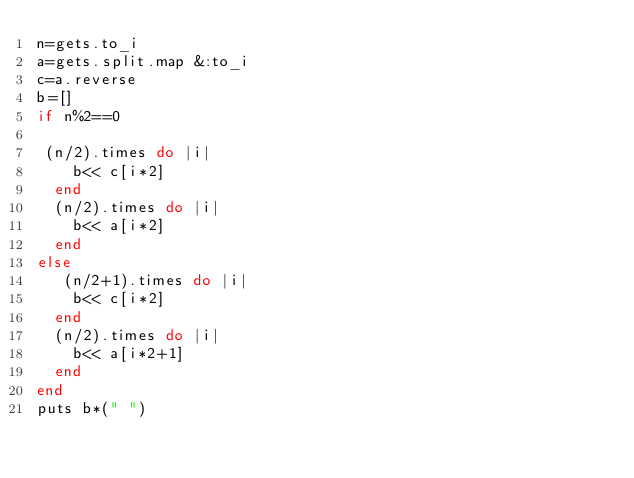<code> <loc_0><loc_0><loc_500><loc_500><_Ruby_>n=gets.to_i
a=gets.split.map &:to_i
c=a.reverse
b=[]
if n%2==0

 (n/2).times do |i|
    b<< c[i*2]
  end
  (n/2).times do |i|
    b<< a[i*2]
  end
else
   (n/2+1).times do |i|
    b<< c[i*2]
  end
  (n/2).times do |i|
    b<< a[i*2+1]
  end
end
puts b*(" ")</code> 